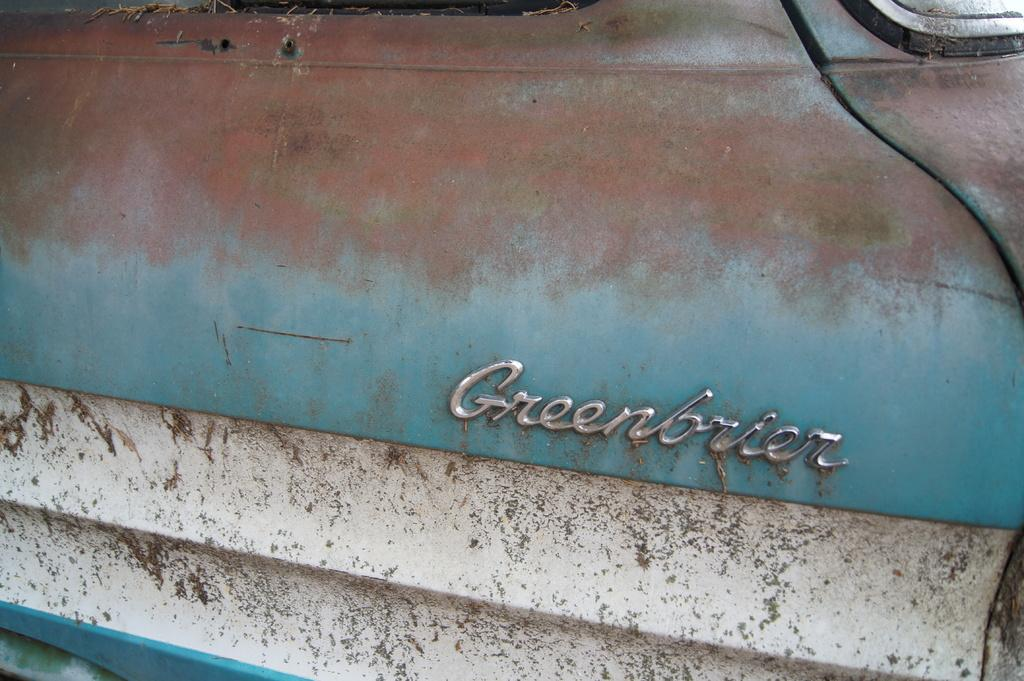What is featured on the vehicle in the image? There is a logo on a vehicle in the image. What type of plantation can be seen growing near the vehicle in the image? There is no plantation present in the image; it only features a logo on a vehicle. 